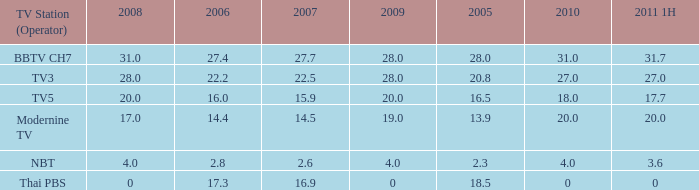How many 2011 1H values have a 2006 of 27.4 and 2007 over 27.7? 0.0. 